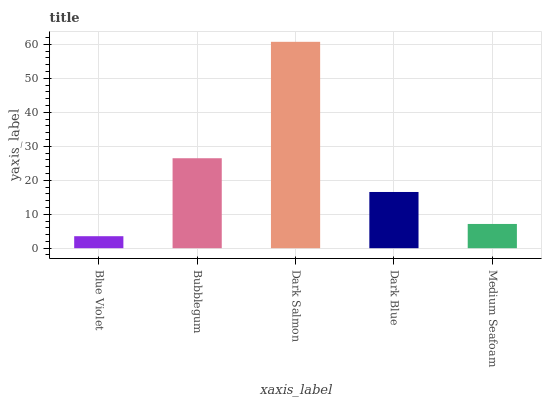Is Blue Violet the minimum?
Answer yes or no. Yes. Is Dark Salmon the maximum?
Answer yes or no. Yes. Is Bubblegum the minimum?
Answer yes or no. No. Is Bubblegum the maximum?
Answer yes or no. No. Is Bubblegum greater than Blue Violet?
Answer yes or no. Yes. Is Blue Violet less than Bubblegum?
Answer yes or no. Yes. Is Blue Violet greater than Bubblegum?
Answer yes or no. No. Is Bubblegum less than Blue Violet?
Answer yes or no. No. Is Dark Blue the high median?
Answer yes or no. Yes. Is Dark Blue the low median?
Answer yes or no. Yes. Is Dark Salmon the high median?
Answer yes or no. No. Is Bubblegum the low median?
Answer yes or no. No. 